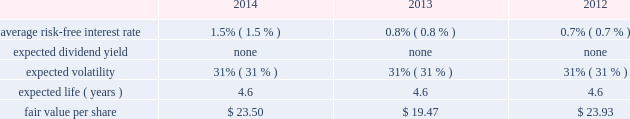Edwards lifesciences corporation notes to consolidated financial statements ( continued ) 13 .
Common stock ( continued ) the company also maintains the nonemployee directors stock incentive compensation program ( the 2018 2018nonemployee directors program 2019 2019 ) .
Under the nonemployee directors program , each nonemployee director may receive annually up to 20000 stock options or 8000 restricted stock units of the company 2019s common stock , or a combination thereof , provided that in no event may the total value of the combined annual award exceed $ 0.2 million .
Each option and restricted stock unit award granted in 2011 or prior generally vests in three equal annual installments .
Each option and restricted stock unit award granted after 2011 generally vests after one year .
Additionally , each nonemployee director may elect to receive all or a portion of the annual cash retainer to which the director is otherwise entitled through the issuance of stock options or restricted shares .
Each option received as a deferral of the cash retainer immediately vests on the grant date , and each restricted share award vests after one year .
Upon a director 2019s initial election to the board , the director receives an initial grant of stock options equal to a fair market value on grant date of $ 0.2 million , not to exceed 10000 shares .
These grants vest over three years from the date of grant .
Under the nonemployee directors program , an aggregate of 1.4 million shares of the company 2019s common stock has been authorized for issuance .
The company has an employee stock purchase plan for united states employees and a plan for international employees ( collectively 2018 2018espp 2019 2019 ) .
Under the espp , eligible employees may purchase shares of the company 2019s common stock at 85% ( 85 % ) of the lower of the fair market value of edwards lifesciences common stock on the effective date of subscription or the date of purchase .
Under the espp , employees can authorize the company to withhold up to 12% ( 12 % ) of their compensation for common stock purchases , subject to certain limitations .
The espp is available to all active employees of the company paid from the united states payroll and to eligible employees of the company outside the united states , to the extent permitted by local law .
The espp for united states employees is qualified under section 423 of the internal revenue code .
The number of shares of common stock authorized for issuance under the espp was 6.9 million shares .
The fair value of each option award and employee stock purchase subscription is estimated on the date of grant using the black-scholes option valuation model that uses the assumptions noted in the tables .
The risk-free interest rate is estimated using the u.s .
Treasury yield curve and is based on the expected term of the award .
Expected volatility is estimated based on a blend of the weighted-average of the historical volatility of edwards lifesciences 2019 stock and the implied volatility from traded options on edwards lifesciences 2019 stock .
The expected term of awards granted is estimated from the vesting period of the award , as well as historical exercise behavior , and represents the period of time that awards granted are expected to be outstanding .
The company uses historical data to estimate forfeitures and has estimated an annual forfeiture rate of 5.4% ( 5.4 % ) .
The black-scholes option pricing model was used with the following weighted-average assumptions for options granted during the following periods : option awards .

What is the expected change according to the model in the fair value per share between 2013 and 2014? 
Computations: (23.50 - 19.47)
Answer: 4.03. 